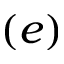<formula> <loc_0><loc_0><loc_500><loc_500>( e )</formula> 